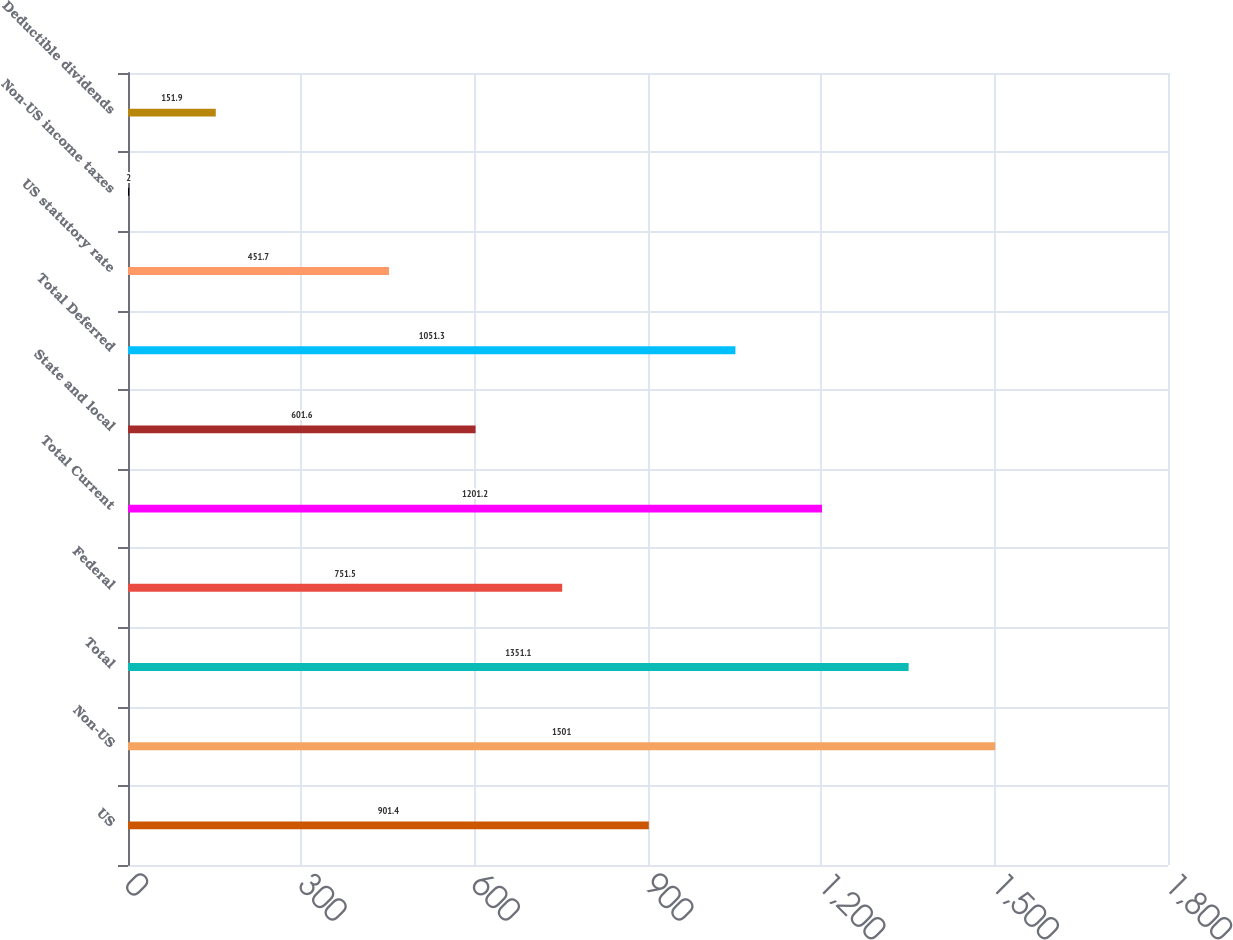<chart> <loc_0><loc_0><loc_500><loc_500><bar_chart><fcel>US<fcel>Non-US<fcel>Total<fcel>Federal<fcel>Total Current<fcel>State and local<fcel>Total Deferred<fcel>US statutory rate<fcel>Non-US income taxes<fcel>Deductible dividends<nl><fcel>901.4<fcel>1501<fcel>1351.1<fcel>751.5<fcel>1201.2<fcel>601.6<fcel>1051.3<fcel>451.7<fcel>2<fcel>151.9<nl></chart> 